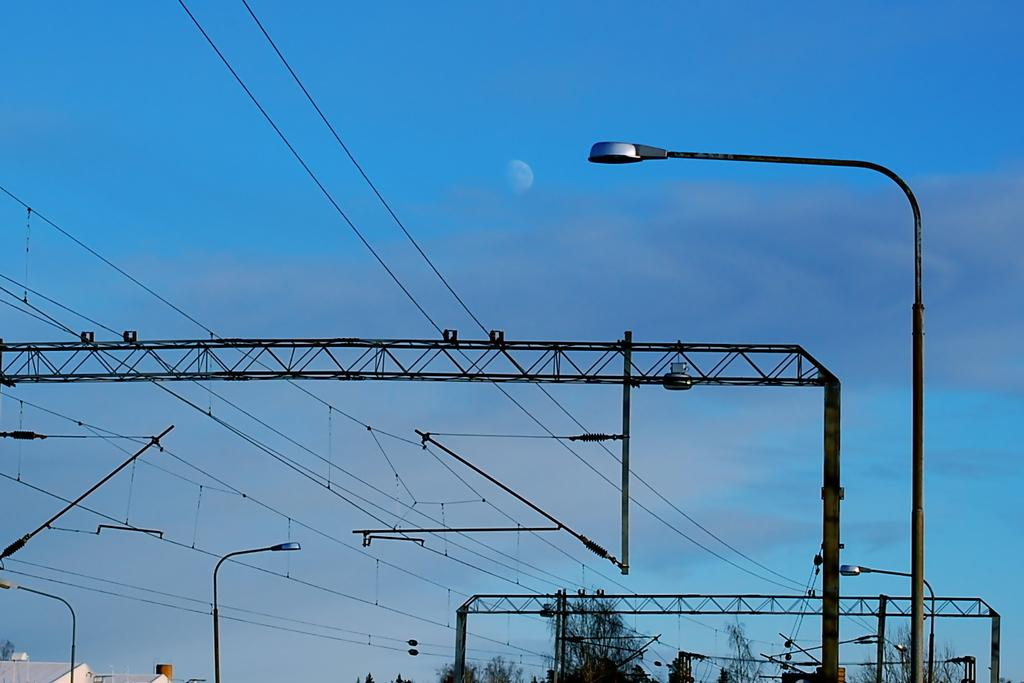What objects are present in the image that resemble long, thin structures? There are rods and poles in the image. What type of natural vegetation can be seen in the image? There are trees in the image. What is visible in the background of the image? The sky is visible in the background of the image. What can be observed in the sky in the image? Clouds are present in the sky. What attraction can be seen in the middle of the image? There is no attraction present in the image; it features rods, poles, trees, and a sky with clouds. How do the trees run in the image? Trees do not run; they are stationary plants in the image. 